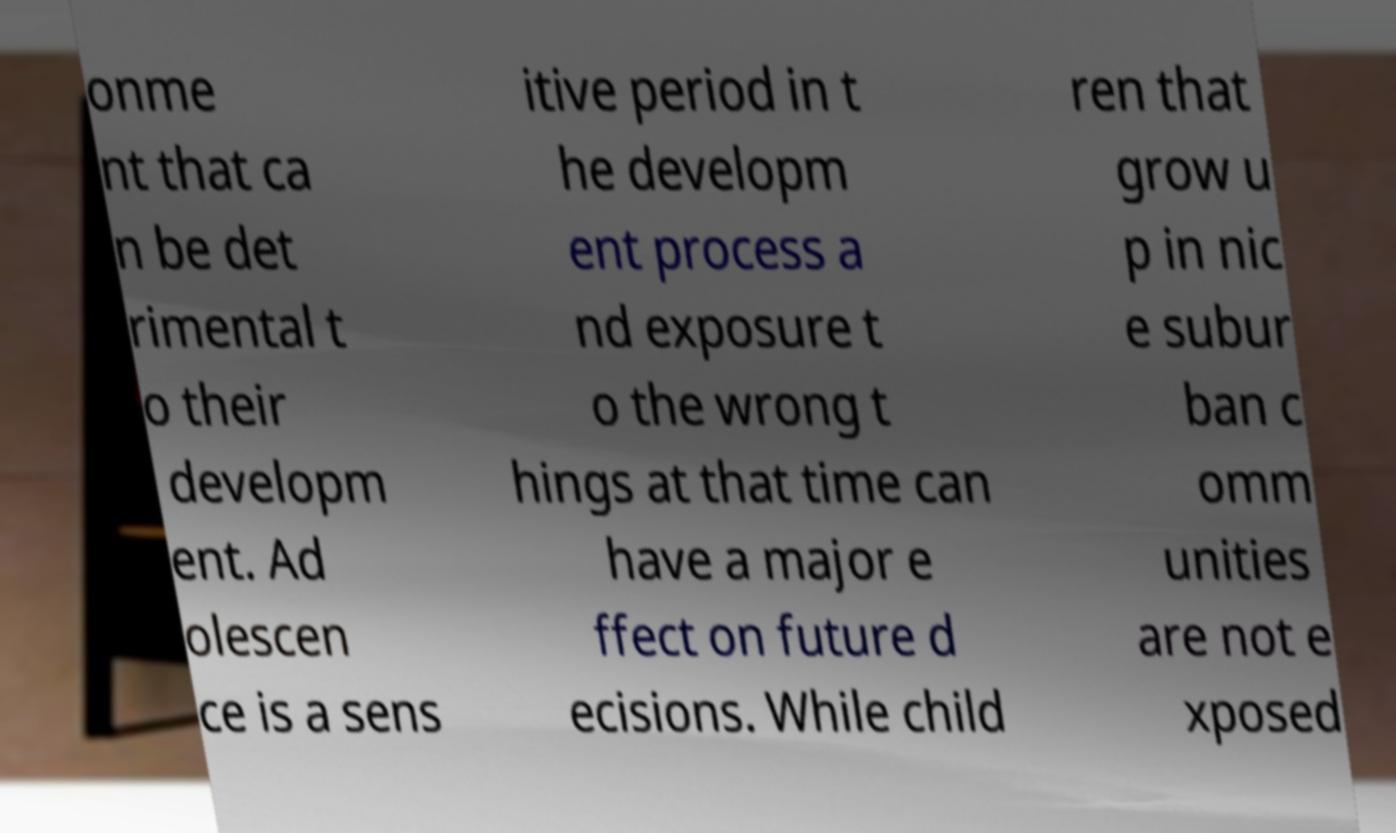Could you extract and type out the text from this image? onme nt that ca n be det rimental t o their developm ent. Ad olescen ce is a sens itive period in t he developm ent process a nd exposure t o the wrong t hings at that time can have a major e ffect on future d ecisions. While child ren that grow u p in nic e subur ban c omm unities are not e xposed 